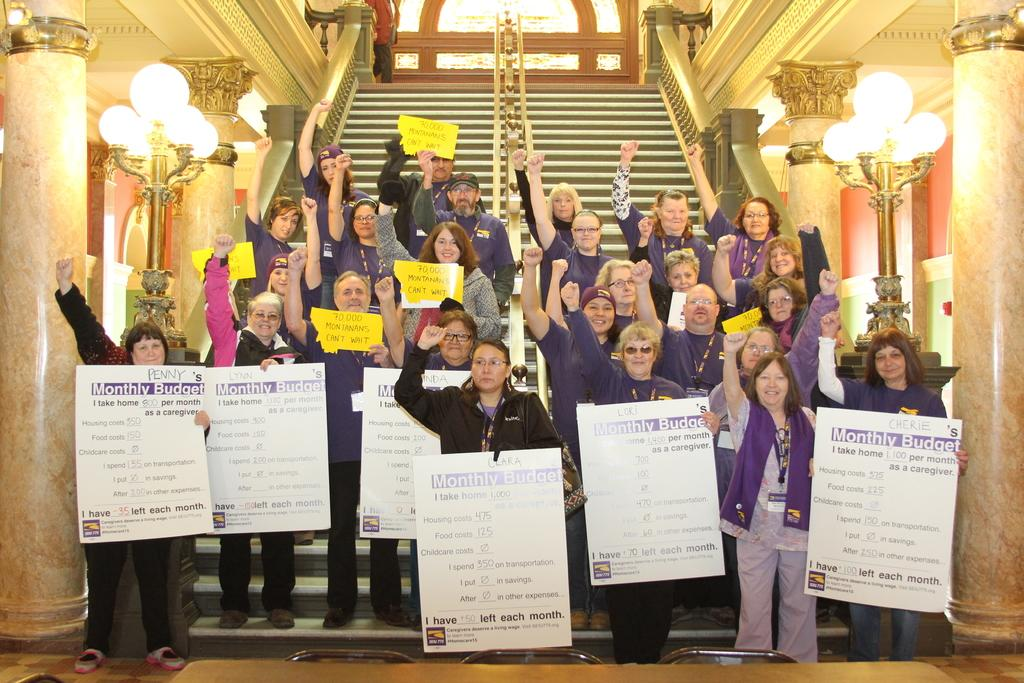How many people are in the image? There is a group of people in the image, but the exact number is not specified. What are the people doing in the image? The people are standing on steps and holding posters. What can be seen in the background of the image? There are pillars, light poles, walls, and other objects visible in the background of the image. What type of whip is being used by the people in the image? There is no whip present in the image; the people are holding posters. What is the position of the event taking place in the image? The image does not indicate the position or location of an event; it only shows a group of people standing on steps and holding posters. 